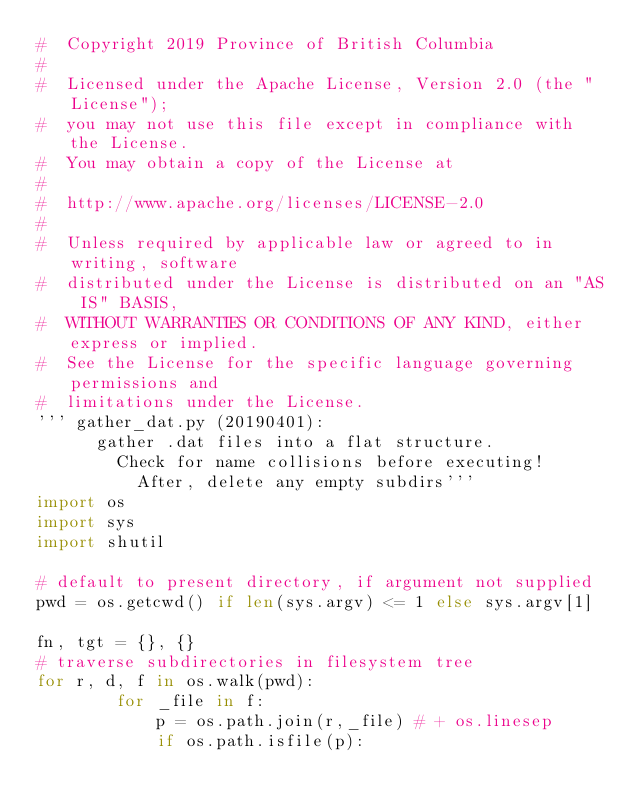<code> <loc_0><loc_0><loc_500><loc_500><_Python_>#  Copyright 2019 Province of British Columbia
#
#  Licensed under the Apache License, Version 2.0 (the "License");
#  you may not use this file except in compliance with the License.
#  You may obtain a copy of the License at
#
#  http://www.apache.org/licenses/LICENSE-2.0
#
#  Unless required by applicable law or agreed to in writing, software
#  distributed under the License is distributed on an "AS IS" BASIS,
#  WITHOUT WARRANTIES OR CONDITIONS OF ANY KIND, either express or implied.
#  See the License for the specific language governing permissions and
#  limitations under the License.
''' gather_dat.py (20190401):
      gather .dat files into a flat structure.
        Check for name collisions before executing!
          After, delete any empty subdirs'''
import os
import sys
import shutil

# default to present directory, if argument not supplied
pwd = os.getcwd() if len(sys.argv) <= 1 else sys.argv[1]

fn, tgt = {}, {}
# traverse subdirectories in filesystem tree
for r, d, f in os.walk(pwd):
        for _file in f:
            p = os.path.join(r,_file) # + os.linesep
            if os.path.isfile(p):</code> 